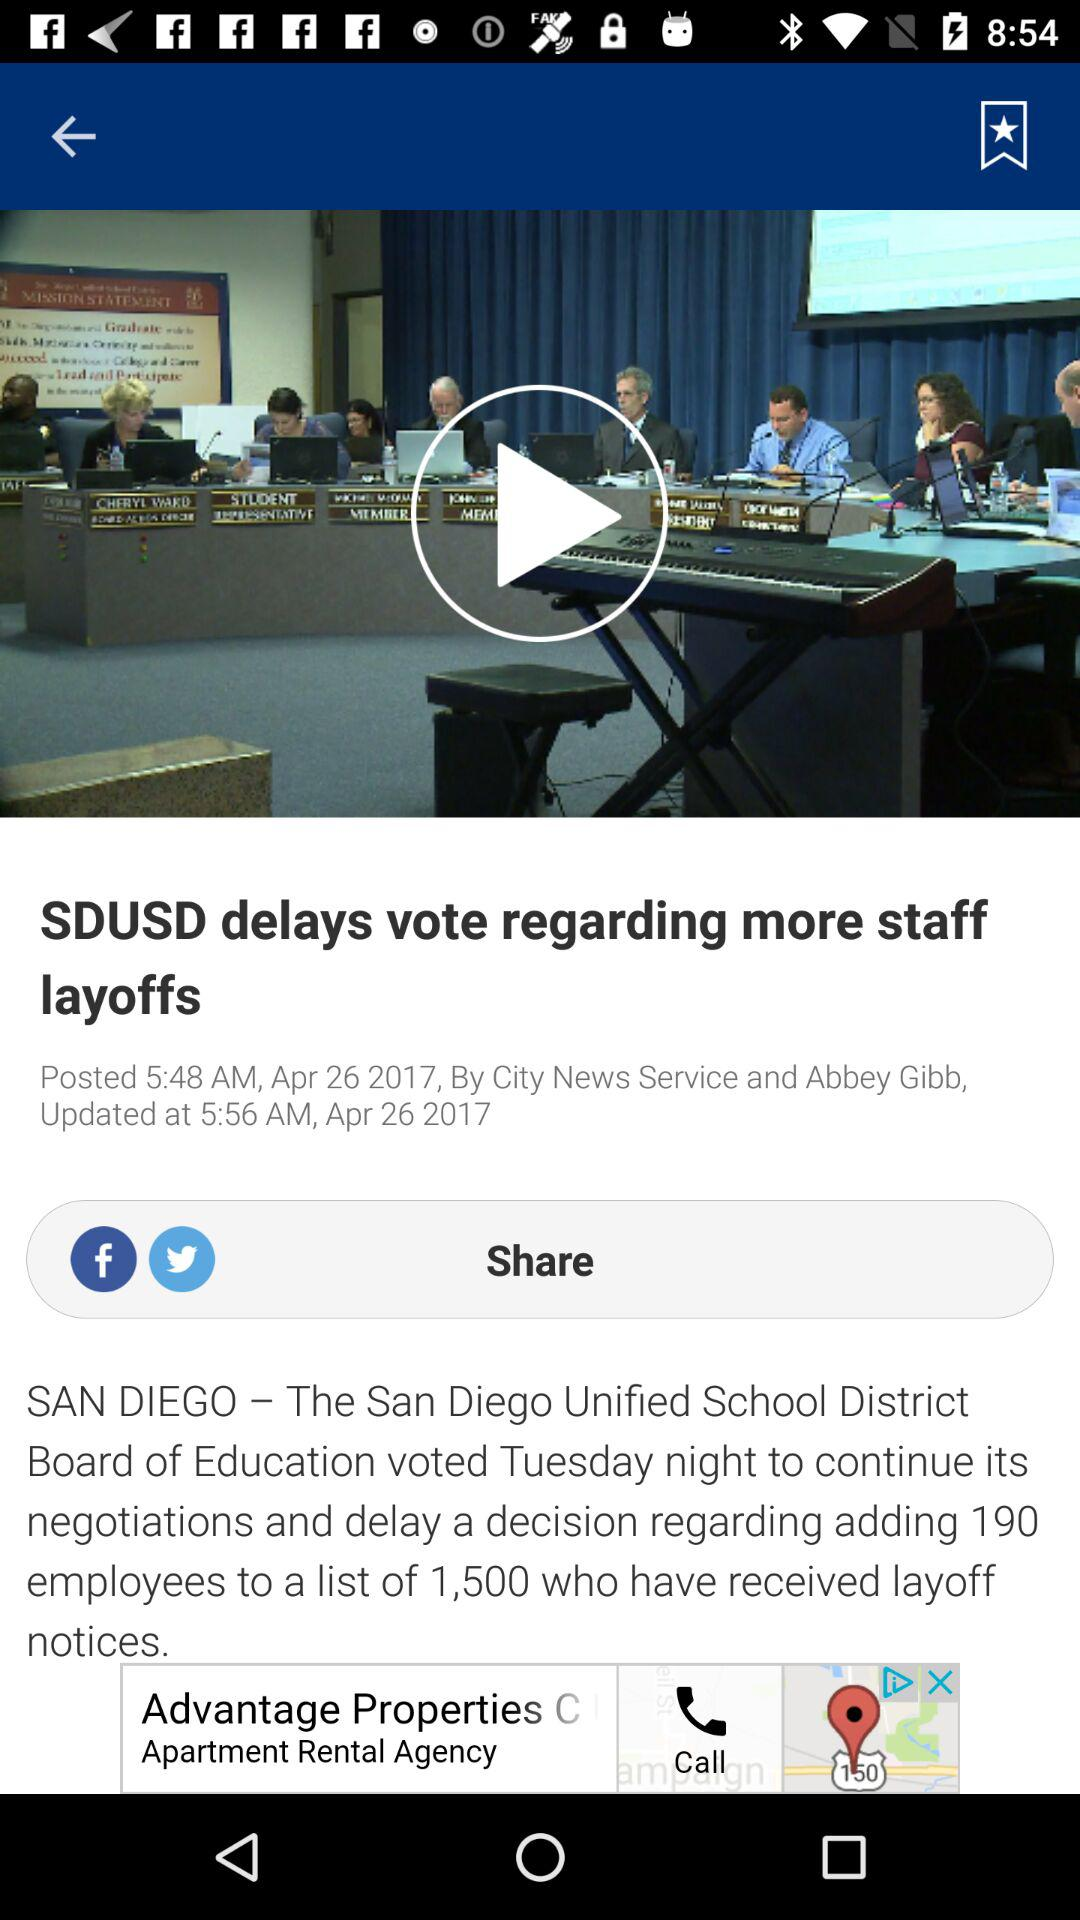What is the updated time? The updated time is 5:56 a.m. 